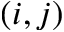Convert formula to latex. <formula><loc_0><loc_0><loc_500><loc_500>( i , j )</formula> 